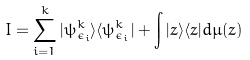Convert formula to latex. <formula><loc_0><loc_0><loc_500><loc_500>I = \sum _ { i = 1 } ^ { k } | \psi _ { \epsilon _ { i } } ^ { k } \rangle \langle \psi _ { \epsilon _ { i } } ^ { k } | + \int | z \rangle \langle z | d \mu ( z )</formula> 